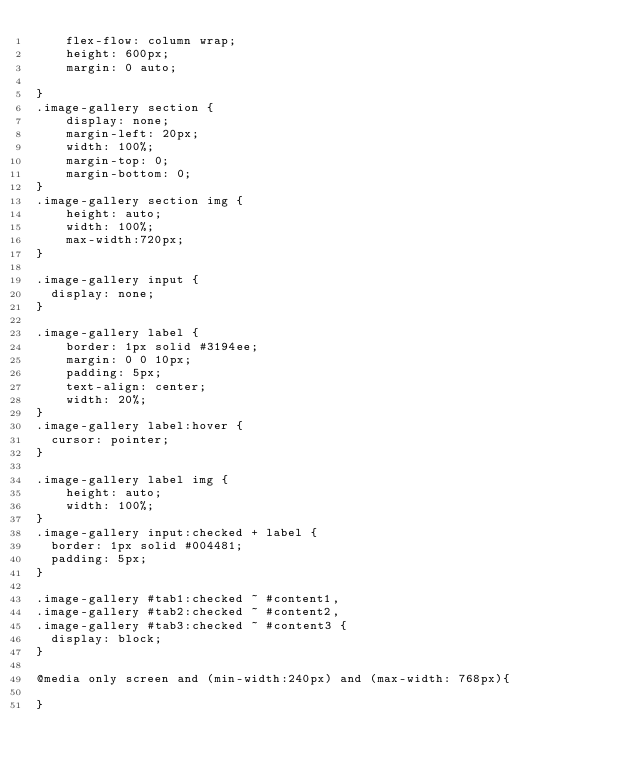Convert code to text. <code><loc_0><loc_0><loc_500><loc_500><_CSS_>    flex-flow: column wrap;
    height: 600px;
    margin: 0 auto;

}
.image-gallery section {
    display: none;
    margin-left: 20px;
	width: 100%;
	margin-top: 0;
	margin-bottom: 0;
}
.image-gallery section img {
    height: auto;
    width: 100%;
	max-width:720px;
}

.image-gallery input {
  display: none;
}

.image-gallery label {
    border: 1px solid #3194ee;
    margin: 0 0 10px;
    padding: 5px;
    text-align: center;
    width: 20%;
}
.image-gallery label:hover {
  cursor: pointer;
}

.image-gallery label img {
    height: auto;
    width: 100%;
}
.image-gallery input:checked + label {
  border: 1px solid #004481;
  padding: 5px;
}

.image-gallery #tab1:checked ~ #content1,
.image-gallery #tab2:checked ~ #content2,
.image-gallery #tab3:checked ~ #content3 {
  display: block;
}

@media only screen and (min-width:240px) and (max-width: 768px){

}
</code> 